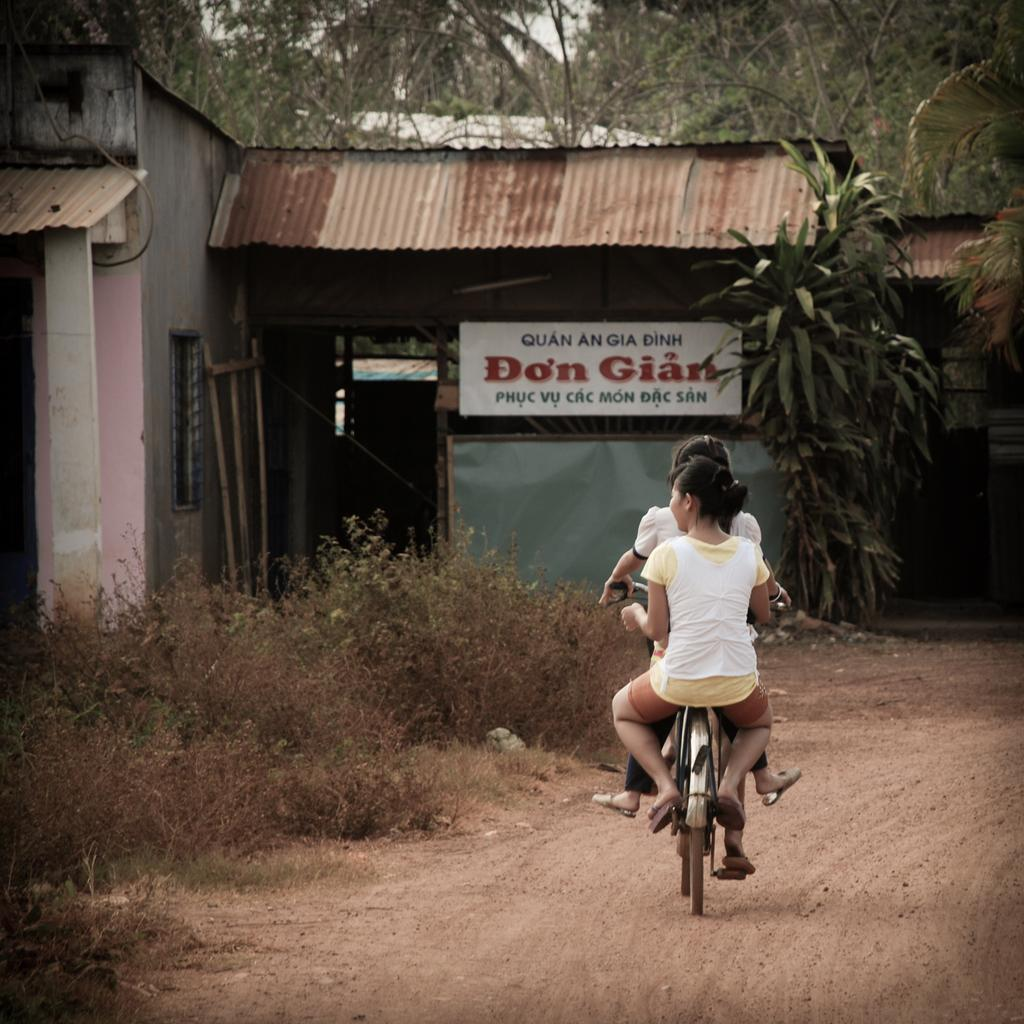What type of vegetation is visible in the image? There are trees in the image. What is the ground covered with in the image? There is grass in the image. What type of structure is present in the image? There is a house in the image. What part of the house is visible in the image? There is a window in the image. What decorative item is present in the image? There is a banner in the image. What mode of transportation can be seen in the image? There are two people on bicycles in the image. How does the zephyr affect the apple tree in the image? There is no mention of a zephyr or an apple tree in the image. How many bikes are present in the image? The image does not show any bikes; it shows two people on bicycles. 